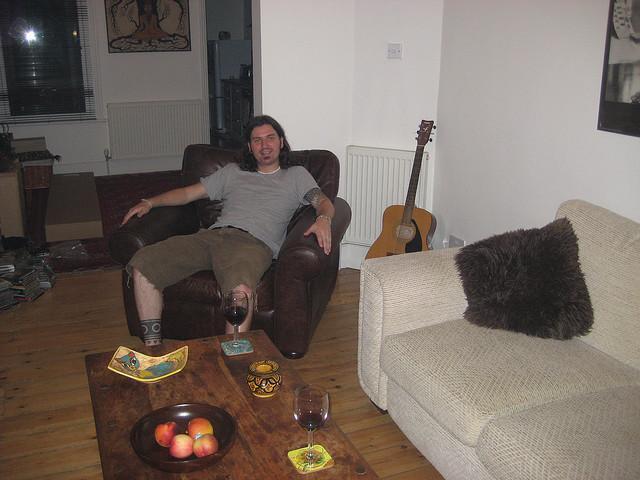How many pillows are on the couch?
Give a very brief answer. 1. How many bowls are there?
Give a very brief answer. 2. How many couches are in the photo?
Give a very brief answer. 3. 